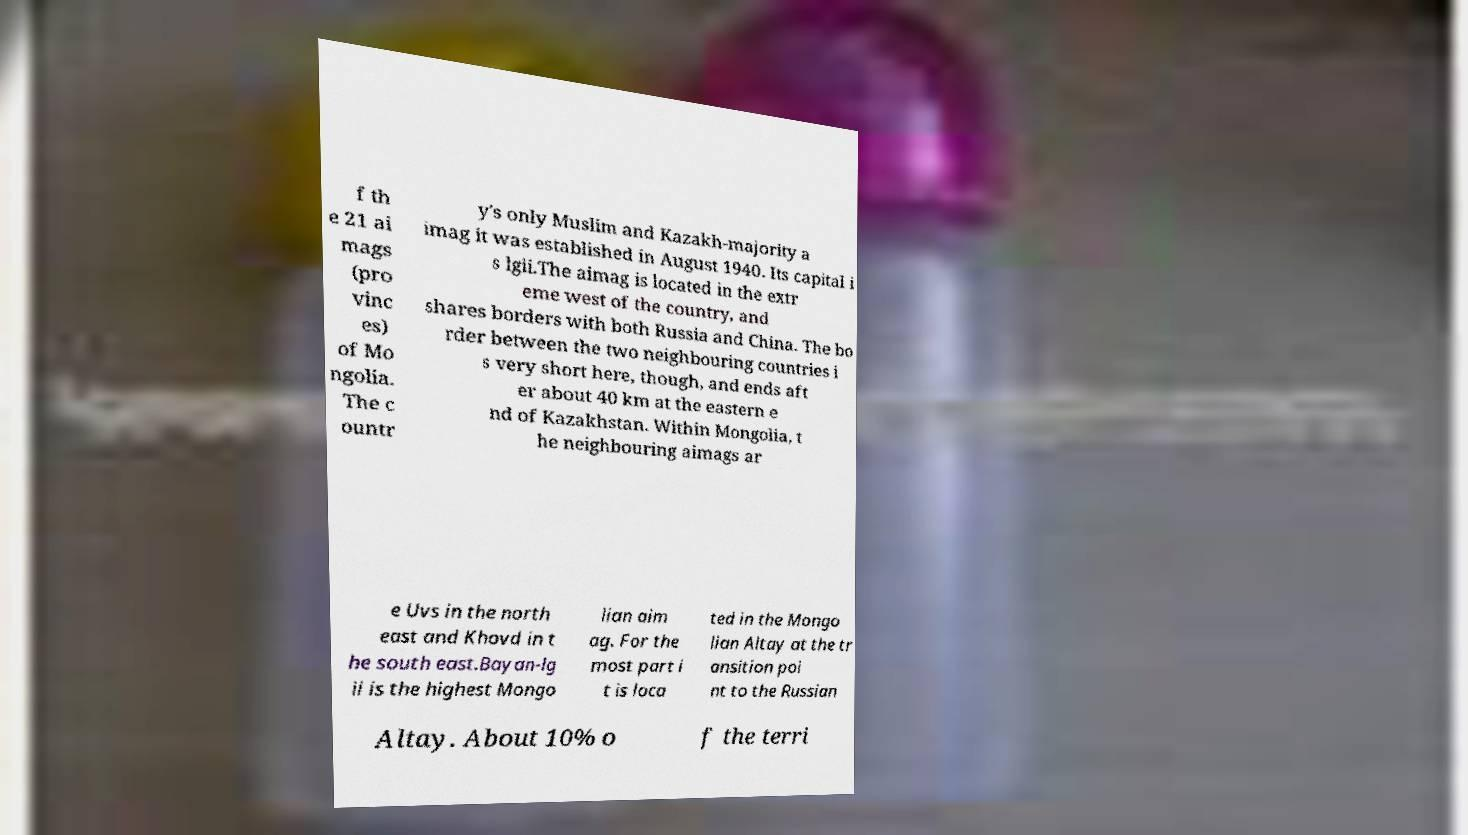For documentation purposes, I need the text within this image transcribed. Could you provide that? f th e 21 ai mags (pro vinc es) of Mo ngolia. The c ountr y's only Muslim and Kazakh-majority a imag it was established in August 1940. Its capital i s lgii.The aimag is located in the extr eme west of the country, and shares borders with both Russia and China. The bo rder between the two neighbouring countries i s very short here, though, and ends aft er about 40 km at the eastern e nd of Kazakhstan. Within Mongolia, t he neighbouring aimags ar e Uvs in the north east and Khovd in t he south east.Bayan-lg ii is the highest Mongo lian aim ag. For the most part i t is loca ted in the Mongo lian Altay at the tr ansition poi nt to the Russian Altay. About 10% o f the terri 